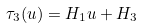<formula> <loc_0><loc_0><loc_500><loc_500>\tau _ { 3 } ( u ) = H _ { 1 } u + H _ { 3 }</formula> 